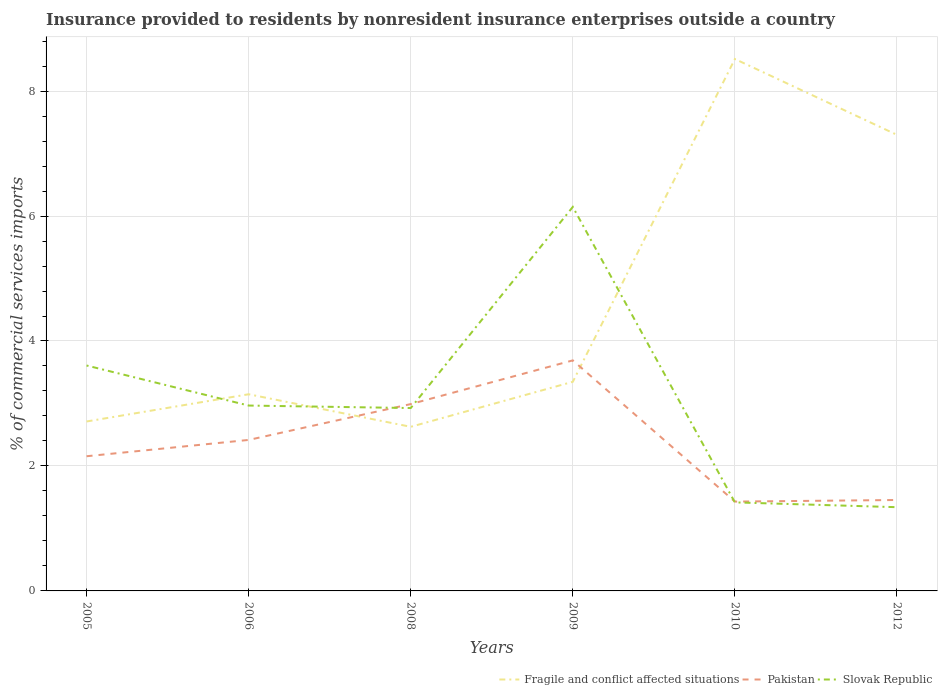How many different coloured lines are there?
Your answer should be compact. 3. Does the line corresponding to Fragile and conflict affected situations intersect with the line corresponding to Slovak Republic?
Your answer should be compact. Yes. Is the number of lines equal to the number of legend labels?
Offer a very short reply. Yes. Across all years, what is the maximum Insurance provided to residents in Fragile and conflict affected situations?
Your answer should be very brief. 2.63. What is the total Insurance provided to residents in Pakistan in the graph?
Give a very brief answer. -0.26. What is the difference between the highest and the second highest Insurance provided to residents in Fragile and conflict affected situations?
Offer a terse response. 5.89. Is the Insurance provided to residents in Pakistan strictly greater than the Insurance provided to residents in Fragile and conflict affected situations over the years?
Your response must be concise. No. What is the difference between two consecutive major ticks on the Y-axis?
Your response must be concise. 2. Are the values on the major ticks of Y-axis written in scientific E-notation?
Give a very brief answer. No. Does the graph contain any zero values?
Your response must be concise. No. Does the graph contain grids?
Provide a short and direct response. Yes. Where does the legend appear in the graph?
Offer a terse response. Bottom right. How many legend labels are there?
Offer a terse response. 3. What is the title of the graph?
Your answer should be very brief. Insurance provided to residents by nonresident insurance enterprises outside a country. Does "Greenland" appear as one of the legend labels in the graph?
Your response must be concise. No. What is the label or title of the X-axis?
Give a very brief answer. Years. What is the label or title of the Y-axis?
Your answer should be very brief. % of commercial services imports. What is the % of commercial services imports of Fragile and conflict affected situations in 2005?
Provide a short and direct response. 2.71. What is the % of commercial services imports in Pakistan in 2005?
Make the answer very short. 2.16. What is the % of commercial services imports of Slovak Republic in 2005?
Ensure brevity in your answer.  3.61. What is the % of commercial services imports of Fragile and conflict affected situations in 2006?
Your answer should be very brief. 3.15. What is the % of commercial services imports in Pakistan in 2006?
Ensure brevity in your answer.  2.42. What is the % of commercial services imports in Slovak Republic in 2006?
Make the answer very short. 2.97. What is the % of commercial services imports in Fragile and conflict affected situations in 2008?
Offer a terse response. 2.63. What is the % of commercial services imports of Pakistan in 2008?
Offer a very short reply. 2.99. What is the % of commercial services imports in Slovak Republic in 2008?
Keep it short and to the point. 2.93. What is the % of commercial services imports in Fragile and conflict affected situations in 2009?
Your answer should be compact. 3.35. What is the % of commercial services imports of Pakistan in 2009?
Ensure brevity in your answer.  3.69. What is the % of commercial services imports of Slovak Republic in 2009?
Your answer should be very brief. 6.15. What is the % of commercial services imports of Fragile and conflict affected situations in 2010?
Keep it short and to the point. 8.51. What is the % of commercial services imports in Pakistan in 2010?
Your answer should be compact. 1.43. What is the % of commercial services imports of Slovak Republic in 2010?
Ensure brevity in your answer.  1.42. What is the % of commercial services imports in Fragile and conflict affected situations in 2012?
Offer a terse response. 7.3. What is the % of commercial services imports of Pakistan in 2012?
Your answer should be very brief. 1.46. What is the % of commercial services imports in Slovak Republic in 2012?
Offer a terse response. 1.34. Across all years, what is the maximum % of commercial services imports in Fragile and conflict affected situations?
Your response must be concise. 8.51. Across all years, what is the maximum % of commercial services imports in Pakistan?
Give a very brief answer. 3.69. Across all years, what is the maximum % of commercial services imports of Slovak Republic?
Your response must be concise. 6.15. Across all years, what is the minimum % of commercial services imports in Fragile and conflict affected situations?
Provide a succinct answer. 2.63. Across all years, what is the minimum % of commercial services imports of Pakistan?
Offer a terse response. 1.43. Across all years, what is the minimum % of commercial services imports of Slovak Republic?
Ensure brevity in your answer.  1.34. What is the total % of commercial services imports of Fragile and conflict affected situations in the graph?
Keep it short and to the point. 27.65. What is the total % of commercial services imports of Pakistan in the graph?
Your answer should be compact. 14.14. What is the total % of commercial services imports in Slovak Republic in the graph?
Provide a short and direct response. 18.4. What is the difference between the % of commercial services imports of Fragile and conflict affected situations in 2005 and that in 2006?
Give a very brief answer. -0.44. What is the difference between the % of commercial services imports of Pakistan in 2005 and that in 2006?
Keep it short and to the point. -0.26. What is the difference between the % of commercial services imports in Slovak Republic in 2005 and that in 2006?
Provide a short and direct response. 0.64. What is the difference between the % of commercial services imports in Fragile and conflict affected situations in 2005 and that in 2008?
Make the answer very short. 0.09. What is the difference between the % of commercial services imports of Pakistan in 2005 and that in 2008?
Offer a terse response. -0.83. What is the difference between the % of commercial services imports of Slovak Republic in 2005 and that in 2008?
Make the answer very short. 0.68. What is the difference between the % of commercial services imports of Fragile and conflict affected situations in 2005 and that in 2009?
Give a very brief answer. -0.64. What is the difference between the % of commercial services imports in Pakistan in 2005 and that in 2009?
Make the answer very short. -1.53. What is the difference between the % of commercial services imports of Slovak Republic in 2005 and that in 2009?
Provide a short and direct response. -2.54. What is the difference between the % of commercial services imports in Fragile and conflict affected situations in 2005 and that in 2010?
Keep it short and to the point. -5.8. What is the difference between the % of commercial services imports in Pakistan in 2005 and that in 2010?
Keep it short and to the point. 0.73. What is the difference between the % of commercial services imports in Slovak Republic in 2005 and that in 2010?
Make the answer very short. 2.19. What is the difference between the % of commercial services imports in Fragile and conflict affected situations in 2005 and that in 2012?
Offer a terse response. -4.59. What is the difference between the % of commercial services imports of Pakistan in 2005 and that in 2012?
Offer a very short reply. 0.7. What is the difference between the % of commercial services imports of Slovak Republic in 2005 and that in 2012?
Keep it short and to the point. 2.27. What is the difference between the % of commercial services imports in Fragile and conflict affected situations in 2006 and that in 2008?
Offer a terse response. 0.52. What is the difference between the % of commercial services imports of Pakistan in 2006 and that in 2008?
Your answer should be compact. -0.57. What is the difference between the % of commercial services imports in Fragile and conflict affected situations in 2006 and that in 2009?
Your answer should be compact. -0.2. What is the difference between the % of commercial services imports of Pakistan in 2006 and that in 2009?
Your response must be concise. -1.27. What is the difference between the % of commercial services imports in Slovak Republic in 2006 and that in 2009?
Your answer should be compact. -3.18. What is the difference between the % of commercial services imports in Fragile and conflict affected situations in 2006 and that in 2010?
Offer a terse response. -5.37. What is the difference between the % of commercial services imports of Pakistan in 2006 and that in 2010?
Provide a short and direct response. 0.99. What is the difference between the % of commercial services imports in Slovak Republic in 2006 and that in 2010?
Ensure brevity in your answer.  1.55. What is the difference between the % of commercial services imports of Fragile and conflict affected situations in 2006 and that in 2012?
Give a very brief answer. -4.15. What is the difference between the % of commercial services imports of Pakistan in 2006 and that in 2012?
Your answer should be compact. 0.96. What is the difference between the % of commercial services imports of Slovak Republic in 2006 and that in 2012?
Ensure brevity in your answer.  1.63. What is the difference between the % of commercial services imports in Fragile and conflict affected situations in 2008 and that in 2009?
Keep it short and to the point. -0.72. What is the difference between the % of commercial services imports in Pakistan in 2008 and that in 2009?
Give a very brief answer. -0.7. What is the difference between the % of commercial services imports in Slovak Republic in 2008 and that in 2009?
Keep it short and to the point. -3.22. What is the difference between the % of commercial services imports of Fragile and conflict affected situations in 2008 and that in 2010?
Your response must be concise. -5.89. What is the difference between the % of commercial services imports in Pakistan in 2008 and that in 2010?
Your answer should be very brief. 1.56. What is the difference between the % of commercial services imports in Slovak Republic in 2008 and that in 2010?
Offer a very short reply. 1.51. What is the difference between the % of commercial services imports in Fragile and conflict affected situations in 2008 and that in 2012?
Make the answer very short. -4.67. What is the difference between the % of commercial services imports of Pakistan in 2008 and that in 2012?
Your answer should be very brief. 1.54. What is the difference between the % of commercial services imports in Slovak Republic in 2008 and that in 2012?
Offer a very short reply. 1.59. What is the difference between the % of commercial services imports of Fragile and conflict affected situations in 2009 and that in 2010?
Your answer should be very brief. -5.17. What is the difference between the % of commercial services imports in Pakistan in 2009 and that in 2010?
Your answer should be very brief. 2.26. What is the difference between the % of commercial services imports of Slovak Republic in 2009 and that in 2010?
Provide a short and direct response. 4.73. What is the difference between the % of commercial services imports in Fragile and conflict affected situations in 2009 and that in 2012?
Give a very brief answer. -3.95. What is the difference between the % of commercial services imports in Pakistan in 2009 and that in 2012?
Your response must be concise. 2.23. What is the difference between the % of commercial services imports in Slovak Republic in 2009 and that in 2012?
Provide a succinct answer. 4.81. What is the difference between the % of commercial services imports in Fragile and conflict affected situations in 2010 and that in 2012?
Provide a succinct answer. 1.21. What is the difference between the % of commercial services imports of Pakistan in 2010 and that in 2012?
Give a very brief answer. -0.03. What is the difference between the % of commercial services imports of Slovak Republic in 2010 and that in 2012?
Offer a very short reply. 0.08. What is the difference between the % of commercial services imports in Fragile and conflict affected situations in 2005 and the % of commercial services imports in Pakistan in 2006?
Keep it short and to the point. 0.3. What is the difference between the % of commercial services imports of Fragile and conflict affected situations in 2005 and the % of commercial services imports of Slovak Republic in 2006?
Offer a very short reply. -0.25. What is the difference between the % of commercial services imports of Pakistan in 2005 and the % of commercial services imports of Slovak Republic in 2006?
Offer a terse response. -0.81. What is the difference between the % of commercial services imports of Fragile and conflict affected situations in 2005 and the % of commercial services imports of Pakistan in 2008?
Provide a short and direct response. -0.28. What is the difference between the % of commercial services imports of Fragile and conflict affected situations in 2005 and the % of commercial services imports of Slovak Republic in 2008?
Your answer should be very brief. -0.21. What is the difference between the % of commercial services imports in Pakistan in 2005 and the % of commercial services imports in Slovak Republic in 2008?
Provide a short and direct response. -0.77. What is the difference between the % of commercial services imports of Fragile and conflict affected situations in 2005 and the % of commercial services imports of Pakistan in 2009?
Provide a short and direct response. -0.98. What is the difference between the % of commercial services imports in Fragile and conflict affected situations in 2005 and the % of commercial services imports in Slovak Republic in 2009?
Provide a succinct answer. -3.43. What is the difference between the % of commercial services imports in Pakistan in 2005 and the % of commercial services imports in Slovak Republic in 2009?
Ensure brevity in your answer.  -3.99. What is the difference between the % of commercial services imports of Fragile and conflict affected situations in 2005 and the % of commercial services imports of Pakistan in 2010?
Your response must be concise. 1.28. What is the difference between the % of commercial services imports in Fragile and conflict affected situations in 2005 and the % of commercial services imports in Slovak Republic in 2010?
Ensure brevity in your answer.  1.29. What is the difference between the % of commercial services imports in Pakistan in 2005 and the % of commercial services imports in Slovak Republic in 2010?
Offer a terse response. 0.74. What is the difference between the % of commercial services imports in Fragile and conflict affected situations in 2005 and the % of commercial services imports in Pakistan in 2012?
Your answer should be very brief. 1.26. What is the difference between the % of commercial services imports in Fragile and conflict affected situations in 2005 and the % of commercial services imports in Slovak Republic in 2012?
Provide a succinct answer. 1.37. What is the difference between the % of commercial services imports of Pakistan in 2005 and the % of commercial services imports of Slovak Republic in 2012?
Offer a very short reply. 0.82. What is the difference between the % of commercial services imports in Fragile and conflict affected situations in 2006 and the % of commercial services imports in Pakistan in 2008?
Your answer should be very brief. 0.16. What is the difference between the % of commercial services imports of Fragile and conflict affected situations in 2006 and the % of commercial services imports of Slovak Republic in 2008?
Provide a succinct answer. 0.22. What is the difference between the % of commercial services imports in Pakistan in 2006 and the % of commercial services imports in Slovak Republic in 2008?
Offer a very short reply. -0.51. What is the difference between the % of commercial services imports in Fragile and conflict affected situations in 2006 and the % of commercial services imports in Pakistan in 2009?
Make the answer very short. -0.54. What is the difference between the % of commercial services imports in Fragile and conflict affected situations in 2006 and the % of commercial services imports in Slovak Republic in 2009?
Your answer should be compact. -3. What is the difference between the % of commercial services imports in Pakistan in 2006 and the % of commercial services imports in Slovak Republic in 2009?
Offer a terse response. -3.73. What is the difference between the % of commercial services imports in Fragile and conflict affected situations in 2006 and the % of commercial services imports in Pakistan in 2010?
Make the answer very short. 1.72. What is the difference between the % of commercial services imports of Fragile and conflict affected situations in 2006 and the % of commercial services imports of Slovak Republic in 2010?
Give a very brief answer. 1.73. What is the difference between the % of commercial services imports of Pakistan in 2006 and the % of commercial services imports of Slovak Republic in 2010?
Your answer should be compact. 1. What is the difference between the % of commercial services imports in Fragile and conflict affected situations in 2006 and the % of commercial services imports in Pakistan in 2012?
Provide a short and direct response. 1.69. What is the difference between the % of commercial services imports of Fragile and conflict affected situations in 2006 and the % of commercial services imports of Slovak Republic in 2012?
Your answer should be very brief. 1.81. What is the difference between the % of commercial services imports in Pakistan in 2006 and the % of commercial services imports in Slovak Republic in 2012?
Offer a very short reply. 1.08. What is the difference between the % of commercial services imports in Fragile and conflict affected situations in 2008 and the % of commercial services imports in Pakistan in 2009?
Provide a succinct answer. -1.06. What is the difference between the % of commercial services imports in Fragile and conflict affected situations in 2008 and the % of commercial services imports in Slovak Republic in 2009?
Give a very brief answer. -3.52. What is the difference between the % of commercial services imports in Pakistan in 2008 and the % of commercial services imports in Slovak Republic in 2009?
Give a very brief answer. -3.16. What is the difference between the % of commercial services imports in Fragile and conflict affected situations in 2008 and the % of commercial services imports in Pakistan in 2010?
Provide a short and direct response. 1.2. What is the difference between the % of commercial services imports of Fragile and conflict affected situations in 2008 and the % of commercial services imports of Slovak Republic in 2010?
Make the answer very short. 1.21. What is the difference between the % of commercial services imports of Pakistan in 2008 and the % of commercial services imports of Slovak Republic in 2010?
Offer a terse response. 1.57. What is the difference between the % of commercial services imports of Fragile and conflict affected situations in 2008 and the % of commercial services imports of Pakistan in 2012?
Your response must be concise. 1.17. What is the difference between the % of commercial services imports of Fragile and conflict affected situations in 2008 and the % of commercial services imports of Slovak Republic in 2012?
Offer a terse response. 1.29. What is the difference between the % of commercial services imports in Pakistan in 2008 and the % of commercial services imports in Slovak Republic in 2012?
Offer a terse response. 1.65. What is the difference between the % of commercial services imports of Fragile and conflict affected situations in 2009 and the % of commercial services imports of Pakistan in 2010?
Ensure brevity in your answer.  1.92. What is the difference between the % of commercial services imports of Fragile and conflict affected situations in 2009 and the % of commercial services imports of Slovak Republic in 2010?
Your answer should be very brief. 1.93. What is the difference between the % of commercial services imports in Pakistan in 2009 and the % of commercial services imports in Slovak Republic in 2010?
Keep it short and to the point. 2.27. What is the difference between the % of commercial services imports in Fragile and conflict affected situations in 2009 and the % of commercial services imports in Pakistan in 2012?
Offer a very short reply. 1.89. What is the difference between the % of commercial services imports in Fragile and conflict affected situations in 2009 and the % of commercial services imports in Slovak Republic in 2012?
Offer a terse response. 2.01. What is the difference between the % of commercial services imports of Pakistan in 2009 and the % of commercial services imports of Slovak Republic in 2012?
Ensure brevity in your answer.  2.35. What is the difference between the % of commercial services imports of Fragile and conflict affected situations in 2010 and the % of commercial services imports of Pakistan in 2012?
Offer a terse response. 7.06. What is the difference between the % of commercial services imports in Fragile and conflict affected situations in 2010 and the % of commercial services imports in Slovak Republic in 2012?
Provide a short and direct response. 7.17. What is the difference between the % of commercial services imports in Pakistan in 2010 and the % of commercial services imports in Slovak Republic in 2012?
Keep it short and to the point. 0.09. What is the average % of commercial services imports in Fragile and conflict affected situations per year?
Your answer should be compact. 4.61. What is the average % of commercial services imports of Pakistan per year?
Offer a very short reply. 2.36. What is the average % of commercial services imports in Slovak Republic per year?
Offer a very short reply. 3.07. In the year 2005, what is the difference between the % of commercial services imports in Fragile and conflict affected situations and % of commercial services imports in Pakistan?
Your response must be concise. 0.56. In the year 2005, what is the difference between the % of commercial services imports in Fragile and conflict affected situations and % of commercial services imports in Slovak Republic?
Provide a short and direct response. -0.9. In the year 2005, what is the difference between the % of commercial services imports in Pakistan and % of commercial services imports in Slovak Republic?
Offer a terse response. -1.45. In the year 2006, what is the difference between the % of commercial services imports in Fragile and conflict affected situations and % of commercial services imports in Pakistan?
Keep it short and to the point. 0.73. In the year 2006, what is the difference between the % of commercial services imports of Fragile and conflict affected situations and % of commercial services imports of Slovak Republic?
Offer a very short reply. 0.18. In the year 2006, what is the difference between the % of commercial services imports of Pakistan and % of commercial services imports of Slovak Republic?
Provide a succinct answer. -0.55. In the year 2008, what is the difference between the % of commercial services imports in Fragile and conflict affected situations and % of commercial services imports in Pakistan?
Your answer should be very brief. -0.36. In the year 2008, what is the difference between the % of commercial services imports in Fragile and conflict affected situations and % of commercial services imports in Slovak Republic?
Offer a terse response. -0.3. In the year 2008, what is the difference between the % of commercial services imports of Pakistan and % of commercial services imports of Slovak Republic?
Offer a terse response. 0.06. In the year 2009, what is the difference between the % of commercial services imports of Fragile and conflict affected situations and % of commercial services imports of Pakistan?
Keep it short and to the point. -0.34. In the year 2009, what is the difference between the % of commercial services imports of Fragile and conflict affected situations and % of commercial services imports of Slovak Republic?
Offer a very short reply. -2.8. In the year 2009, what is the difference between the % of commercial services imports of Pakistan and % of commercial services imports of Slovak Republic?
Offer a terse response. -2.46. In the year 2010, what is the difference between the % of commercial services imports in Fragile and conflict affected situations and % of commercial services imports in Pakistan?
Make the answer very short. 7.08. In the year 2010, what is the difference between the % of commercial services imports in Fragile and conflict affected situations and % of commercial services imports in Slovak Republic?
Offer a very short reply. 7.1. In the year 2010, what is the difference between the % of commercial services imports in Pakistan and % of commercial services imports in Slovak Republic?
Ensure brevity in your answer.  0.01. In the year 2012, what is the difference between the % of commercial services imports in Fragile and conflict affected situations and % of commercial services imports in Pakistan?
Give a very brief answer. 5.84. In the year 2012, what is the difference between the % of commercial services imports of Fragile and conflict affected situations and % of commercial services imports of Slovak Republic?
Provide a short and direct response. 5.96. In the year 2012, what is the difference between the % of commercial services imports in Pakistan and % of commercial services imports in Slovak Republic?
Provide a succinct answer. 0.12. What is the ratio of the % of commercial services imports in Fragile and conflict affected situations in 2005 to that in 2006?
Ensure brevity in your answer.  0.86. What is the ratio of the % of commercial services imports in Pakistan in 2005 to that in 2006?
Your response must be concise. 0.89. What is the ratio of the % of commercial services imports in Slovak Republic in 2005 to that in 2006?
Your answer should be compact. 1.22. What is the ratio of the % of commercial services imports in Fragile and conflict affected situations in 2005 to that in 2008?
Your response must be concise. 1.03. What is the ratio of the % of commercial services imports of Pakistan in 2005 to that in 2008?
Offer a terse response. 0.72. What is the ratio of the % of commercial services imports in Slovak Republic in 2005 to that in 2008?
Provide a short and direct response. 1.23. What is the ratio of the % of commercial services imports in Fragile and conflict affected situations in 2005 to that in 2009?
Keep it short and to the point. 0.81. What is the ratio of the % of commercial services imports of Pakistan in 2005 to that in 2009?
Your response must be concise. 0.58. What is the ratio of the % of commercial services imports in Slovak Republic in 2005 to that in 2009?
Ensure brevity in your answer.  0.59. What is the ratio of the % of commercial services imports in Fragile and conflict affected situations in 2005 to that in 2010?
Your answer should be compact. 0.32. What is the ratio of the % of commercial services imports of Pakistan in 2005 to that in 2010?
Provide a short and direct response. 1.51. What is the ratio of the % of commercial services imports of Slovak Republic in 2005 to that in 2010?
Your answer should be compact. 2.55. What is the ratio of the % of commercial services imports in Fragile and conflict affected situations in 2005 to that in 2012?
Your answer should be very brief. 0.37. What is the ratio of the % of commercial services imports of Pakistan in 2005 to that in 2012?
Your answer should be compact. 1.48. What is the ratio of the % of commercial services imports of Slovak Republic in 2005 to that in 2012?
Your response must be concise. 2.69. What is the ratio of the % of commercial services imports in Fragile and conflict affected situations in 2006 to that in 2008?
Keep it short and to the point. 1.2. What is the ratio of the % of commercial services imports of Pakistan in 2006 to that in 2008?
Provide a succinct answer. 0.81. What is the ratio of the % of commercial services imports of Slovak Republic in 2006 to that in 2008?
Offer a terse response. 1.01. What is the ratio of the % of commercial services imports in Fragile and conflict affected situations in 2006 to that in 2009?
Provide a short and direct response. 0.94. What is the ratio of the % of commercial services imports in Pakistan in 2006 to that in 2009?
Ensure brevity in your answer.  0.66. What is the ratio of the % of commercial services imports of Slovak Republic in 2006 to that in 2009?
Give a very brief answer. 0.48. What is the ratio of the % of commercial services imports in Fragile and conflict affected situations in 2006 to that in 2010?
Your response must be concise. 0.37. What is the ratio of the % of commercial services imports in Pakistan in 2006 to that in 2010?
Ensure brevity in your answer.  1.69. What is the ratio of the % of commercial services imports of Slovak Republic in 2006 to that in 2010?
Your answer should be compact. 2.09. What is the ratio of the % of commercial services imports in Fragile and conflict affected situations in 2006 to that in 2012?
Ensure brevity in your answer.  0.43. What is the ratio of the % of commercial services imports of Pakistan in 2006 to that in 2012?
Ensure brevity in your answer.  1.66. What is the ratio of the % of commercial services imports of Slovak Republic in 2006 to that in 2012?
Offer a terse response. 2.21. What is the ratio of the % of commercial services imports in Fragile and conflict affected situations in 2008 to that in 2009?
Keep it short and to the point. 0.78. What is the ratio of the % of commercial services imports of Pakistan in 2008 to that in 2009?
Your answer should be compact. 0.81. What is the ratio of the % of commercial services imports in Slovak Republic in 2008 to that in 2009?
Offer a terse response. 0.48. What is the ratio of the % of commercial services imports in Fragile and conflict affected situations in 2008 to that in 2010?
Give a very brief answer. 0.31. What is the ratio of the % of commercial services imports of Pakistan in 2008 to that in 2010?
Make the answer very short. 2.09. What is the ratio of the % of commercial services imports in Slovak Republic in 2008 to that in 2010?
Your response must be concise. 2.07. What is the ratio of the % of commercial services imports of Fragile and conflict affected situations in 2008 to that in 2012?
Provide a short and direct response. 0.36. What is the ratio of the % of commercial services imports of Pakistan in 2008 to that in 2012?
Offer a very short reply. 2.05. What is the ratio of the % of commercial services imports in Slovak Republic in 2008 to that in 2012?
Your answer should be compact. 2.18. What is the ratio of the % of commercial services imports of Fragile and conflict affected situations in 2009 to that in 2010?
Offer a very short reply. 0.39. What is the ratio of the % of commercial services imports in Pakistan in 2009 to that in 2010?
Your answer should be compact. 2.58. What is the ratio of the % of commercial services imports in Slovak Republic in 2009 to that in 2010?
Ensure brevity in your answer.  4.34. What is the ratio of the % of commercial services imports of Fragile and conflict affected situations in 2009 to that in 2012?
Offer a terse response. 0.46. What is the ratio of the % of commercial services imports in Pakistan in 2009 to that in 2012?
Provide a succinct answer. 2.54. What is the ratio of the % of commercial services imports of Slovak Republic in 2009 to that in 2012?
Offer a terse response. 4.59. What is the ratio of the % of commercial services imports in Fragile and conflict affected situations in 2010 to that in 2012?
Make the answer very short. 1.17. What is the ratio of the % of commercial services imports of Pakistan in 2010 to that in 2012?
Your answer should be very brief. 0.98. What is the ratio of the % of commercial services imports in Slovak Republic in 2010 to that in 2012?
Provide a succinct answer. 1.06. What is the difference between the highest and the second highest % of commercial services imports in Fragile and conflict affected situations?
Offer a terse response. 1.21. What is the difference between the highest and the second highest % of commercial services imports in Pakistan?
Make the answer very short. 0.7. What is the difference between the highest and the second highest % of commercial services imports in Slovak Republic?
Make the answer very short. 2.54. What is the difference between the highest and the lowest % of commercial services imports of Fragile and conflict affected situations?
Your answer should be compact. 5.89. What is the difference between the highest and the lowest % of commercial services imports of Pakistan?
Give a very brief answer. 2.26. What is the difference between the highest and the lowest % of commercial services imports of Slovak Republic?
Offer a very short reply. 4.81. 